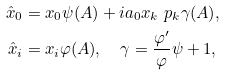Convert formula to latex. <formula><loc_0><loc_0><loc_500><loc_500>\hat { x } _ { 0 } & = x _ { 0 } \psi ( A ) + i a _ { 0 } x _ { k } \ p _ { k } \gamma ( A ) , \\ \hat { x } _ { i } & = x _ { i } \varphi ( A ) , \quad \gamma = \frac { \varphi ^ { \prime } } { \varphi } \psi + 1 ,</formula> 